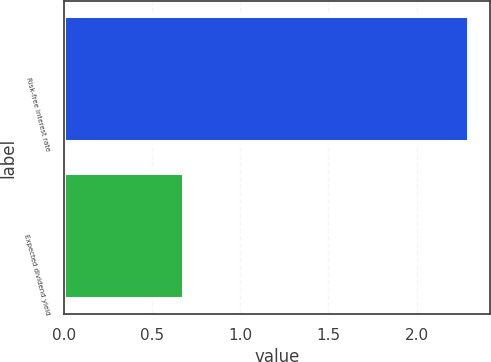Convert chart to OTSL. <chart><loc_0><loc_0><loc_500><loc_500><bar_chart><fcel>Risk-free interest rate<fcel>Expected dividend yield<nl><fcel>2.3<fcel>0.68<nl></chart> 